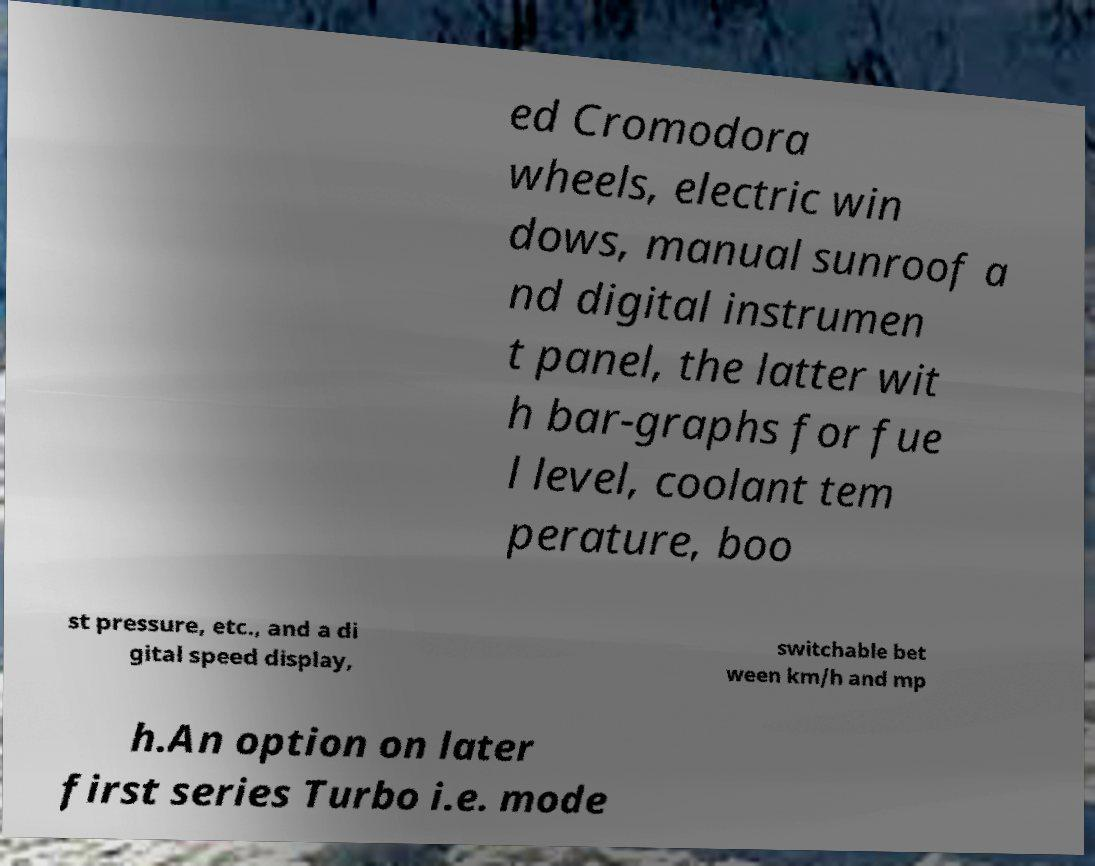What messages or text are displayed in this image? I need them in a readable, typed format. ed Cromodora wheels, electric win dows, manual sunroof a nd digital instrumen t panel, the latter wit h bar-graphs for fue l level, coolant tem perature, boo st pressure, etc., and a di gital speed display, switchable bet ween km/h and mp h.An option on later first series Turbo i.e. mode 